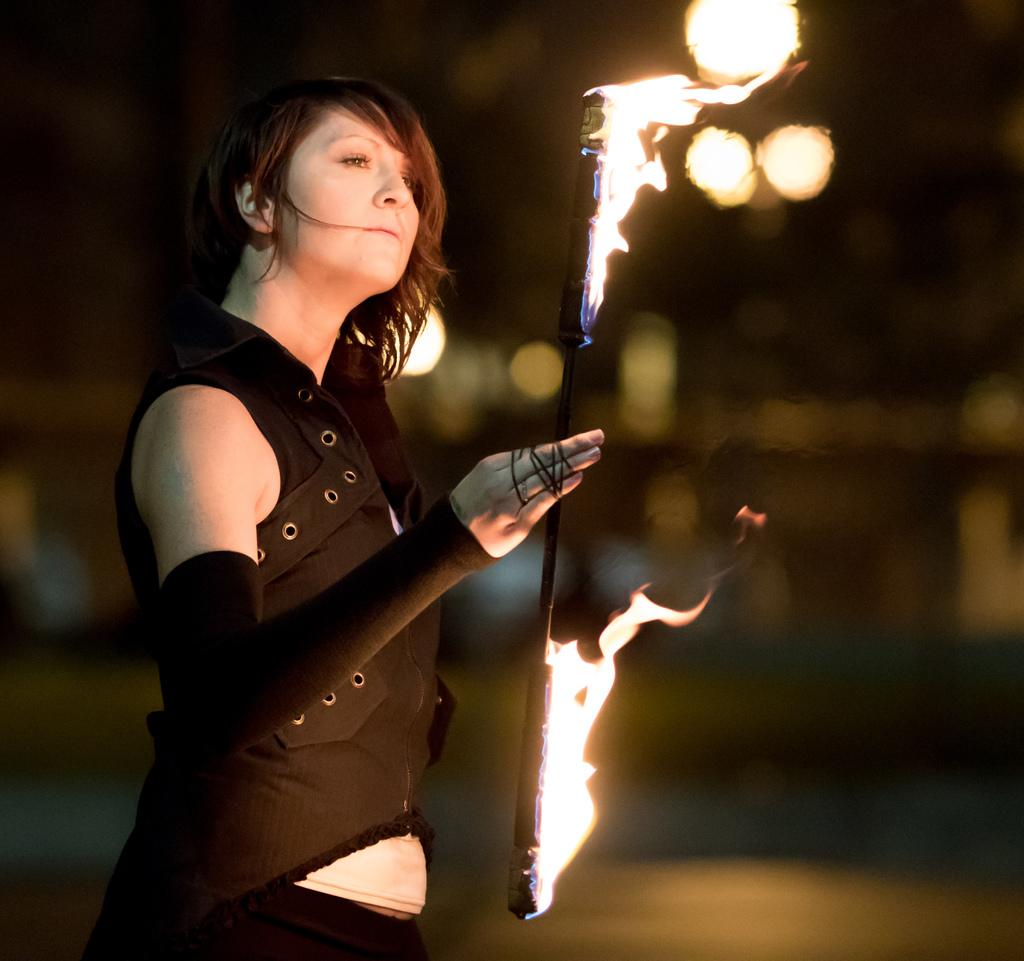What is the main subject of the image? There is a person in the image. What is the person doing in the image? The person is standing and holding a stick with fire. Can you describe the background of the image? The background of the image is blurred. What type of suit is the person wearing in the image? There is no suit visible in the image; the person is holding a stick with fire. How many fangs can be seen on the person in the image? There are no fangs present in the image; the person is holding a stick with fire. 